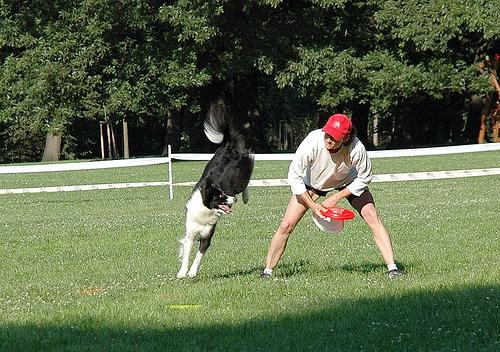What is the color of the baseball cap in the image? The baseball cap is red. What is the interaction between the person and the dog in this image? The person is playing with the dog, holding two frisbees while the dog is jumping in the air. Briefly describe the setting of the image. The setting has green trees in the background, a white wooden fence, a grassy area with shadows, and small white flowers in the grass. What type of clothing is the person wearing in the picture? The person is wearing a white long-sleeved shirt, shorts, and a red baseball hat. Identify the colors of the two frisbees in the person's hands. One frisbee is red and the other one is white. Count the number of flowers and describe their color. There are tiny white flowers in the shade. Explain the presence of the yellow patch on the ground and the sentiment of the whole image. The yellow patch is a yellow frisbee lying in the grass, and the overall sentiment is joyful, with the person and dog playing together. Describe the appearance of the dog in the image. The dog is black and white, has a long bushy tail, and its tongue is sticking out. How many frisbees are there in the image and what are their colors? There are three frisbees: one red, one white, and one yellow. What is happening with the dog in the picture? The dog is jumping and excited, with its front legs and tongue visible. How many flowers are present in the image? Tiny white flowers in the shade How many frisbees is the person holding? Two frisbees What brand name is printed on the red baseball cap? There is no mention of a brand name. Where is the black and white dog located in the image? X:158 Y:94 Width:99 Height:99 Is there a yellow frisbee in the image? Yes, there is a yellow frisbee in the grass. What type of hat is the person wearing? A red baseball cap Is there any suspicious or unusual activity in the image? No Point out the location of the person wearing a red hat. X:303 Y:113 Width:60 Height:60 Which of the following is NOT in the image: a) A black and white dog b) A red frisbee c) A purple hat A purple hat How does the dog and the frisbees interact in this image? The dog is jumping in the air, potentially catching or playing with the frisbees. Identify the object located at X:164 Y:299 Width:42 Height:42. A yellow patch on the ground What is the mood of the dog in the image? Excited Identify the kind of animal present in the image. A dog Identify the color of the fence. White Describe the position of the dog's tongue. The dog's tongue is sticking out. Describe the fence present in the image. A white wooden fence List the colors of the frisbees in the image. Red, white, and yellow Rate the image's sharpness and brightness. Sharp and well-lit 